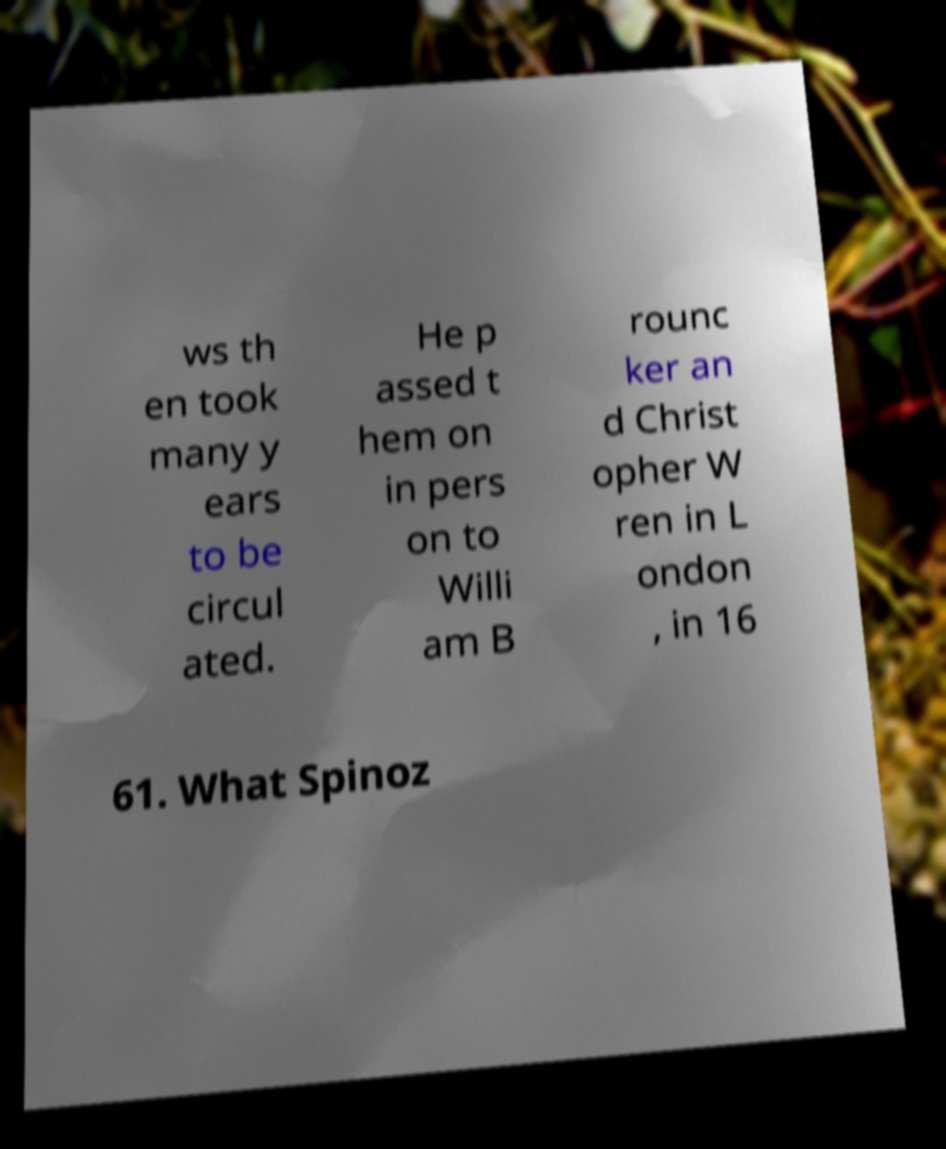What messages or text are displayed in this image? I need them in a readable, typed format. ws th en took many y ears to be circul ated. He p assed t hem on in pers on to Willi am B rounc ker an d Christ opher W ren in L ondon , in 16 61. What Spinoz 